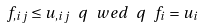Convert formula to latex. <formula><loc_0><loc_0><loc_500><loc_500>\ f _ { , i j } \leq u _ { , i j } \ q \ w e d \ q \ f _ { i } = u _ { i }</formula> 